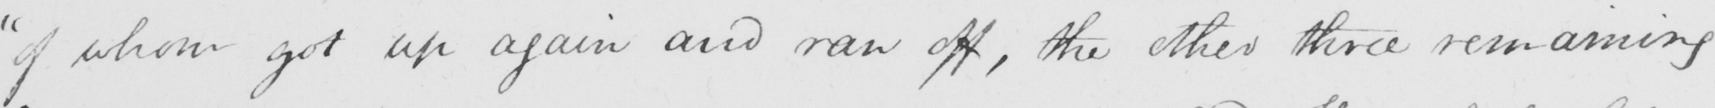Transcribe the text shown in this historical manuscript line. " of whom got up again and ran off , the other three remaining 